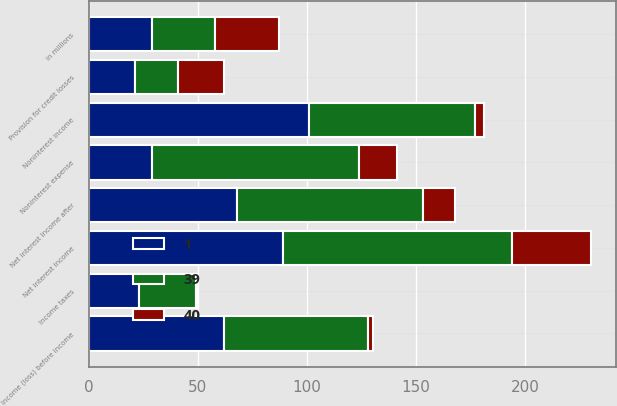Convert chart. <chart><loc_0><loc_0><loc_500><loc_500><stacked_bar_chart><ecel><fcel>in millions<fcel>Net interest income<fcel>Provision for credit losses<fcel>Net interest income after<fcel>Noninterest income<fcel>Noninterest expense<fcel>Income (loss) before income<fcel>Income taxes<nl><fcel>40<fcel>29<fcel>36<fcel>21<fcel>15<fcel>4<fcel>17<fcel>2<fcel>1<nl><fcel>1<fcel>29<fcel>89<fcel>21<fcel>68<fcel>101<fcel>29<fcel>62<fcel>23<nl><fcel>39<fcel>29<fcel>105<fcel>20<fcel>85<fcel>76<fcel>95<fcel>66<fcel>26<nl></chart> 